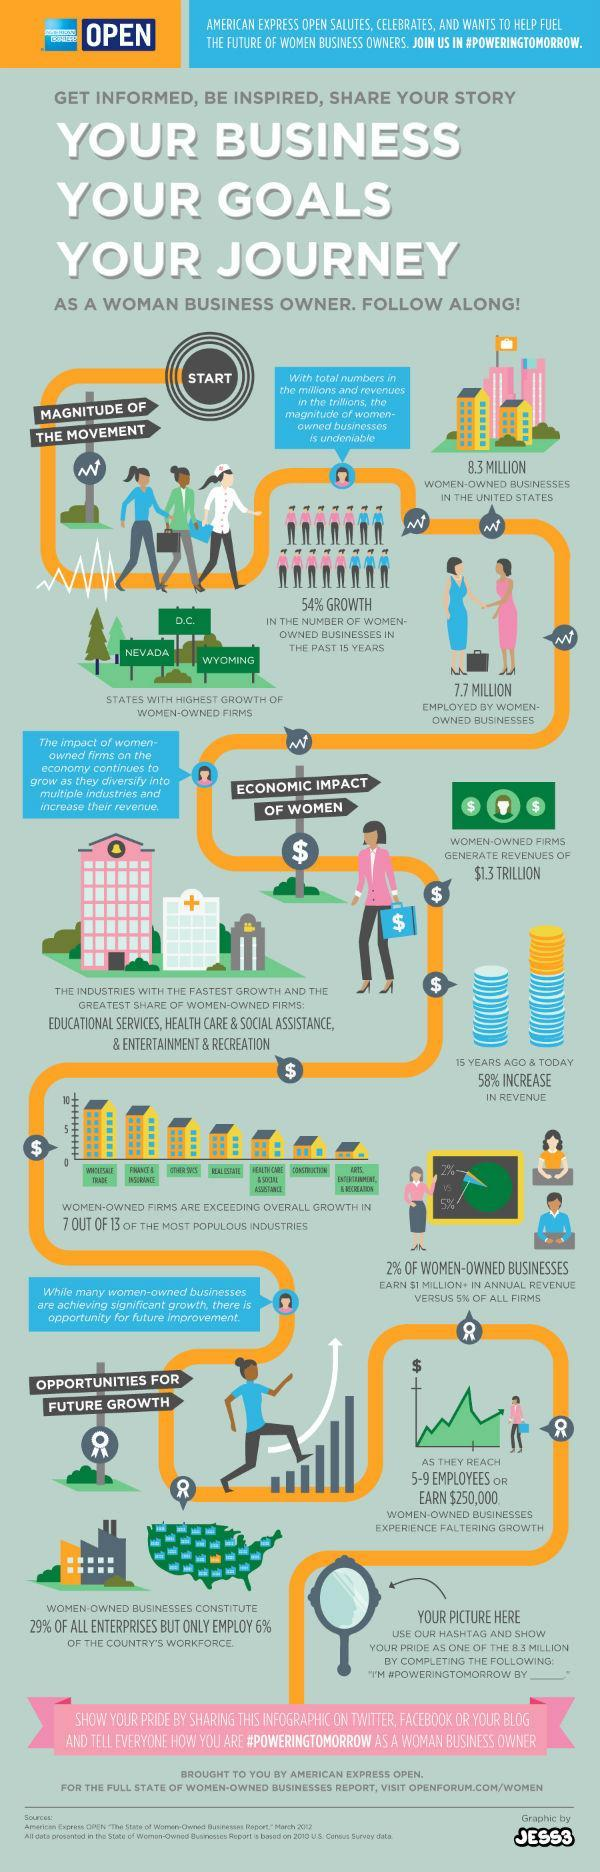How many employed in women-owned businesses?
Answer the question with a short phrase. 7.7 million How many women-owned businesses in the United States? 8.3 million 